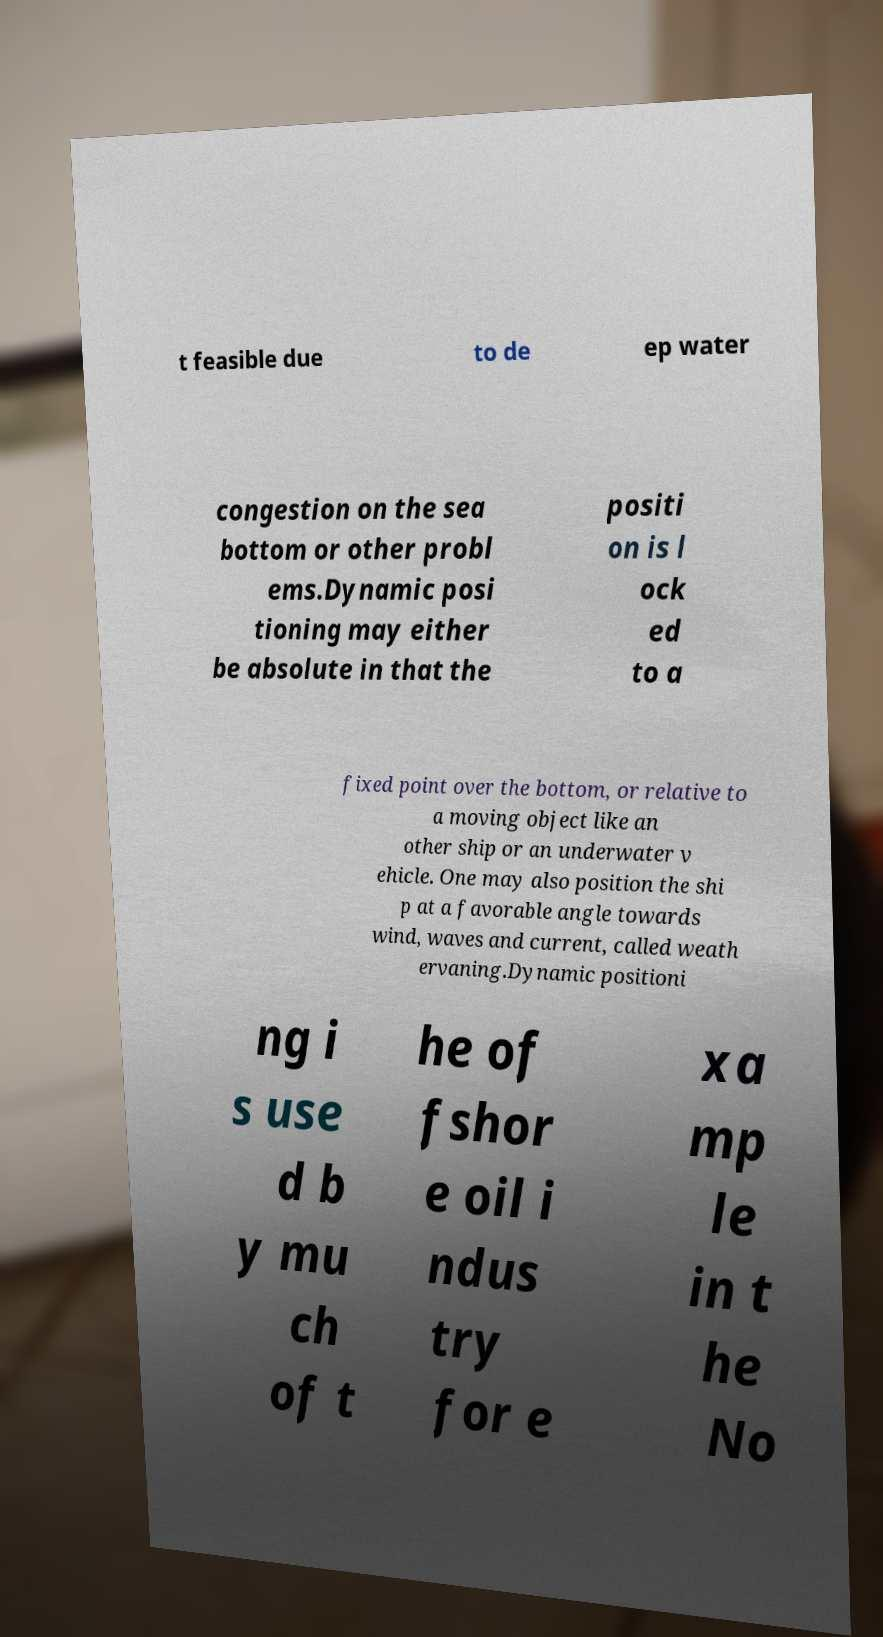Could you assist in decoding the text presented in this image and type it out clearly? t feasible due to de ep water congestion on the sea bottom or other probl ems.Dynamic posi tioning may either be absolute in that the positi on is l ock ed to a fixed point over the bottom, or relative to a moving object like an other ship or an underwater v ehicle. One may also position the shi p at a favorable angle towards wind, waves and current, called weath ervaning.Dynamic positioni ng i s use d b y mu ch of t he of fshor e oil i ndus try for e xa mp le in t he No 